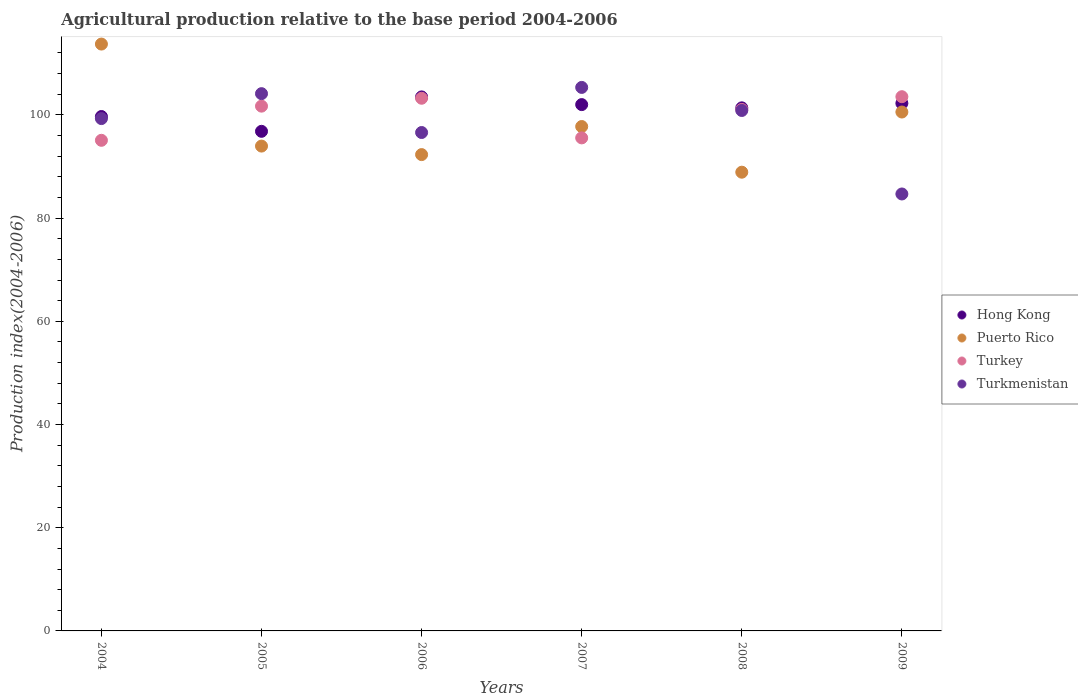How many different coloured dotlines are there?
Keep it short and to the point. 4. Is the number of dotlines equal to the number of legend labels?
Keep it short and to the point. Yes. What is the agricultural production index in Hong Kong in 2009?
Your response must be concise. 102.25. Across all years, what is the maximum agricultural production index in Hong Kong?
Provide a short and direct response. 103.49. Across all years, what is the minimum agricultural production index in Puerto Rico?
Give a very brief answer. 88.9. What is the total agricultural production index in Turkmenistan in the graph?
Make the answer very short. 590.87. What is the difference between the agricultural production index in Turkmenistan in 2004 and that in 2009?
Your response must be concise. 14.61. What is the difference between the agricultural production index in Hong Kong in 2009 and the agricultural production index in Puerto Rico in 2008?
Your answer should be compact. 13.35. What is the average agricultural production index in Puerto Rico per year?
Provide a short and direct response. 97.87. In the year 2005, what is the difference between the agricultural production index in Hong Kong and agricultural production index in Turkey?
Make the answer very short. -4.88. In how many years, is the agricultural production index in Turkmenistan greater than 92?
Give a very brief answer. 5. What is the ratio of the agricultural production index in Puerto Rico in 2006 to that in 2008?
Offer a very short reply. 1.04. Is the agricultural production index in Puerto Rico in 2004 less than that in 2008?
Offer a terse response. No. What is the difference between the highest and the second highest agricultural production index in Puerto Rico?
Offer a terse response. 13.17. What is the difference between the highest and the lowest agricultural production index in Turkey?
Your answer should be very brief. 8.45. In how many years, is the agricultural production index in Turkey greater than the average agricultural production index in Turkey taken over all years?
Give a very brief answer. 4. Is it the case that in every year, the sum of the agricultural production index in Turkmenistan and agricultural production index in Hong Kong  is greater than the agricultural production index in Puerto Rico?
Your response must be concise. Yes. Does the agricultural production index in Turkmenistan monotonically increase over the years?
Your answer should be very brief. No. Is the agricultural production index in Puerto Rico strictly greater than the agricultural production index in Turkmenistan over the years?
Provide a short and direct response. No. How many dotlines are there?
Ensure brevity in your answer.  4. How many years are there in the graph?
Your answer should be compact. 6. What is the difference between two consecutive major ticks on the Y-axis?
Ensure brevity in your answer.  20. Does the graph contain any zero values?
Provide a short and direct response. No. Where does the legend appear in the graph?
Keep it short and to the point. Center right. How are the legend labels stacked?
Ensure brevity in your answer.  Vertical. What is the title of the graph?
Offer a terse response. Agricultural production relative to the base period 2004-2006. Does "Liberia" appear as one of the legend labels in the graph?
Give a very brief answer. No. What is the label or title of the Y-axis?
Offer a terse response. Production index(2004-2006). What is the Production index(2004-2006) of Hong Kong in 2004?
Your answer should be compact. 99.69. What is the Production index(2004-2006) in Puerto Rico in 2004?
Offer a very short reply. 113.73. What is the Production index(2004-2006) in Turkey in 2004?
Your answer should be very brief. 95.08. What is the Production index(2004-2006) in Turkmenistan in 2004?
Give a very brief answer. 99.29. What is the Production index(2004-2006) in Hong Kong in 2005?
Ensure brevity in your answer.  96.82. What is the Production index(2004-2006) of Puerto Rico in 2005?
Your answer should be compact. 93.96. What is the Production index(2004-2006) of Turkey in 2005?
Provide a succinct answer. 101.7. What is the Production index(2004-2006) of Turkmenistan in 2005?
Provide a succinct answer. 104.12. What is the Production index(2004-2006) of Hong Kong in 2006?
Keep it short and to the point. 103.49. What is the Production index(2004-2006) in Puerto Rico in 2006?
Provide a short and direct response. 92.31. What is the Production index(2004-2006) in Turkey in 2006?
Give a very brief answer. 103.23. What is the Production index(2004-2006) of Turkmenistan in 2006?
Your answer should be compact. 96.59. What is the Production index(2004-2006) in Hong Kong in 2007?
Offer a terse response. 102. What is the Production index(2004-2006) in Puerto Rico in 2007?
Make the answer very short. 97.75. What is the Production index(2004-2006) of Turkey in 2007?
Your response must be concise. 95.55. What is the Production index(2004-2006) in Turkmenistan in 2007?
Your answer should be compact. 105.33. What is the Production index(2004-2006) of Hong Kong in 2008?
Ensure brevity in your answer.  101.37. What is the Production index(2004-2006) of Puerto Rico in 2008?
Keep it short and to the point. 88.9. What is the Production index(2004-2006) of Turkey in 2008?
Your answer should be compact. 101.06. What is the Production index(2004-2006) of Turkmenistan in 2008?
Your response must be concise. 100.86. What is the Production index(2004-2006) in Hong Kong in 2009?
Your answer should be very brief. 102.25. What is the Production index(2004-2006) in Puerto Rico in 2009?
Provide a succinct answer. 100.56. What is the Production index(2004-2006) in Turkey in 2009?
Make the answer very short. 103.53. What is the Production index(2004-2006) of Turkmenistan in 2009?
Give a very brief answer. 84.68. Across all years, what is the maximum Production index(2004-2006) in Hong Kong?
Your response must be concise. 103.49. Across all years, what is the maximum Production index(2004-2006) of Puerto Rico?
Keep it short and to the point. 113.73. Across all years, what is the maximum Production index(2004-2006) of Turkey?
Your response must be concise. 103.53. Across all years, what is the maximum Production index(2004-2006) of Turkmenistan?
Your answer should be compact. 105.33. Across all years, what is the minimum Production index(2004-2006) of Hong Kong?
Provide a succinct answer. 96.82. Across all years, what is the minimum Production index(2004-2006) of Puerto Rico?
Ensure brevity in your answer.  88.9. Across all years, what is the minimum Production index(2004-2006) of Turkey?
Offer a very short reply. 95.08. Across all years, what is the minimum Production index(2004-2006) of Turkmenistan?
Your answer should be compact. 84.68. What is the total Production index(2004-2006) in Hong Kong in the graph?
Your answer should be very brief. 605.62. What is the total Production index(2004-2006) in Puerto Rico in the graph?
Provide a succinct answer. 587.21. What is the total Production index(2004-2006) in Turkey in the graph?
Provide a succinct answer. 600.15. What is the total Production index(2004-2006) in Turkmenistan in the graph?
Offer a terse response. 590.87. What is the difference between the Production index(2004-2006) in Hong Kong in 2004 and that in 2005?
Offer a very short reply. 2.87. What is the difference between the Production index(2004-2006) in Puerto Rico in 2004 and that in 2005?
Give a very brief answer. 19.77. What is the difference between the Production index(2004-2006) of Turkey in 2004 and that in 2005?
Offer a terse response. -6.62. What is the difference between the Production index(2004-2006) of Turkmenistan in 2004 and that in 2005?
Your answer should be compact. -4.83. What is the difference between the Production index(2004-2006) in Puerto Rico in 2004 and that in 2006?
Ensure brevity in your answer.  21.42. What is the difference between the Production index(2004-2006) of Turkey in 2004 and that in 2006?
Provide a short and direct response. -8.15. What is the difference between the Production index(2004-2006) in Turkmenistan in 2004 and that in 2006?
Give a very brief answer. 2.7. What is the difference between the Production index(2004-2006) of Hong Kong in 2004 and that in 2007?
Keep it short and to the point. -2.31. What is the difference between the Production index(2004-2006) in Puerto Rico in 2004 and that in 2007?
Your answer should be compact. 15.98. What is the difference between the Production index(2004-2006) of Turkey in 2004 and that in 2007?
Ensure brevity in your answer.  -0.47. What is the difference between the Production index(2004-2006) in Turkmenistan in 2004 and that in 2007?
Keep it short and to the point. -6.04. What is the difference between the Production index(2004-2006) of Hong Kong in 2004 and that in 2008?
Provide a short and direct response. -1.68. What is the difference between the Production index(2004-2006) of Puerto Rico in 2004 and that in 2008?
Make the answer very short. 24.83. What is the difference between the Production index(2004-2006) in Turkey in 2004 and that in 2008?
Make the answer very short. -5.98. What is the difference between the Production index(2004-2006) in Turkmenistan in 2004 and that in 2008?
Provide a short and direct response. -1.57. What is the difference between the Production index(2004-2006) of Hong Kong in 2004 and that in 2009?
Your answer should be very brief. -2.56. What is the difference between the Production index(2004-2006) in Puerto Rico in 2004 and that in 2009?
Offer a terse response. 13.17. What is the difference between the Production index(2004-2006) in Turkey in 2004 and that in 2009?
Keep it short and to the point. -8.45. What is the difference between the Production index(2004-2006) of Turkmenistan in 2004 and that in 2009?
Offer a very short reply. 14.61. What is the difference between the Production index(2004-2006) of Hong Kong in 2005 and that in 2006?
Ensure brevity in your answer.  -6.67. What is the difference between the Production index(2004-2006) in Puerto Rico in 2005 and that in 2006?
Your response must be concise. 1.65. What is the difference between the Production index(2004-2006) of Turkey in 2005 and that in 2006?
Offer a terse response. -1.53. What is the difference between the Production index(2004-2006) in Turkmenistan in 2005 and that in 2006?
Offer a very short reply. 7.53. What is the difference between the Production index(2004-2006) in Hong Kong in 2005 and that in 2007?
Provide a succinct answer. -5.18. What is the difference between the Production index(2004-2006) in Puerto Rico in 2005 and that in 2007?
Your answer should be compact. -3.79. What is the difference between the Production index(2004-2006) of Turkey in 2005 and that in 2007?
Make the answer very short. 6.15. What is the difference between the Production index(2004-2006) of Turkmenistan in 2005 and that in 2007?
Offer a terse response. -1.21. What is the difference between the Production index(2004-2006) in Hong Kong in 2005 and that in 2008?
Offer a very short reply. -4.55. What is the difference between the Production index(2004-2006) of Puerto Rico in 2005 and that in 2008?
Your answer should be compact. 5.06. What is the difference between the Production index(2004-2006) in Turkey in 2005 and that in 2008?
Your response must be concise. 0.64. What is the difference between the Production index(2004-2006) in Turkmenistan in 2005 and that in 2008?
Keep it short and to the point. 3.26. What is the difference between the Production index(2004-2006) in Hong Kong in 2005 and that in 2009?
Your answer should be compact. -5.43. What is the difference between the Production index(2004-2006) in Puerto Rico in 2005 and that in 2009?
Make the answer very short. -6.6. What is the difference between the Production index(2004-2006) of Turkey in 2005 and that in 2009?
Ensure brevity in your answer.  -1.83. What is the difference between the Production index(2004-2006) in Turkmenistan in 2005 and that in 2009?
Make the answer very short. 19.44. What is the difference between the Production index(2004-2006) in Hong Kong in 2006 and that in 2007?
Your answer should be very brief. 1.49. What is the difference between the Production index(2004-2006) in Puerto Rico in 2006 and that in 2007?
Provide a succinct answer. -5.44. What is the difference between the Production index(2004-2006) in Turkey in 2006 and that in 2007?
Your answer should be compact. 7.68. What is the difference between the Production index(2004-2006) in Turkmenistan in 2006 and that in 2007?
Offer a terse response. -8.74. What is the difference between the Production index(2004-2006) in Hong Kong in 2006 and that in 2008?
Your answer should be compact. 2.12. What is the difference between the Production index(2004-2006) in Puerto Rico in 2006 and that in 2008?
Your response must be concise. 3.41. What is the difference between the Production index(2004-2006) in Turkey in 2006 and that in 2008?
Provide a short and direct response. 2.17. What is the difference between the Production index(2004-2006) of Turkmenistan in 2006 and that in 2008?
Give a very brief answer. -4.27. What is the difference between the Production index(2004-2006) in Hong Kong in 2006 and that in 2009?
Provide a succinct answer. 1.24. What is the difference between the Production index(2004-2006) in Puerto Rico in 2006 and that in 2009?
Give a very brief answer. -8.25. What is the difference between the Production index(2004-2006) of Turkmenistan in 2006 and that in 2009?
Ensure brevity in your answer.  11.91. What is the difference between the Production index(2004-2006) of Hong Kong in 2007 and that in 2008?
Your answer should be very brief. 0.63. What is the difference between the Production index(2004-2006) of Puerto Rico in 2007 and that in 2008?
Give a very brief answer. 8.85. What is the difference between the Production index(2004-2006) of Turkey in 2007 and that in 2008?
Make the answer very short. -5.51. What is the difference between the Production index(2004-2006) in Turkmenistan in 2007 and that in 2008?
Offer a very short reply. 4.47. What is the difference between the Production index(2004-2006) in Hong Kong in 2007 and that in 2009?
Your response must be concise. -0.25. What is the difference between the Production index(2004-2006) of Puerto Rico in 2007 and that in 2009?
Make the answer very short. -2.81. What is the difference between the Production index(2004-2006) of Turkey in 2007 and that in 2009?
Ensure brevity in your answer.  -7.98. What is the difference between the Production index(2004-2006) in Turkmenistan in 2007 and that in 2009?
Offer a very short reply. 20.65. What is the difference between the Production index(2004-2006) of Hong Kong in 2008 and that in 2009?
Your answer should be very brief. -0.88. What is the difference between the Production index(2004-2006) of Puerto Rico in 2008 and that in 2009?
Provide a short and direct response. -11.66. What is the difference between the Production index(2004-2006) in Turkey in 2008 and that in 2009?
Your answer should be compact. -2.47. What is the difference between the Production index(2004-2006) in Turkmenistan in 2008 and that in 2009?
Your answer should be compact. 16.18. What is the difference between the Production index(2004-2006) in Hong Kong in 2004 and the Production index(2004-2006) in Puerto Rico in 2005?
Offer a very short reply. 5.73. What is the difference between the Production index(2004-2006) in Hong Kong in 2004 and the Production index(2004-2006) in Turkey in 2005?
Offer a terse response. -2.01. What is the difference between the Production index(2004-2006) of Hong Kong in 2004 and the Production index(2004-2006) of Turkmenistan in 2005?
Keep it short and to the point. -4.43. What is the difference between the Production index(2004-2006) of Puerto Rico in 2004 and the Production index(2004-2006) of Turkey in 2005?
Your response must be concise. 12.03. What is the difference between the Production index(2004-2006) of Puerto Rico in 2004 and the Production index(2004-2006) of Turkmenistan in 2005?
Keep it short and to the point. 9.61. What is the difference between the Production index(2004-2006) of Turkey in 2004 and the Production index(2004-2006) of Turkmenistan in 2005?
Offer a very short reply. -9.04. What is the difference between the Production index(2004-2006) in Hong Kong in 2004 and the Production index(2004-2006) in Puerto Rico in 2006?
Your answer should be very brief. 7.38. What is the difference between the Production index(2004-2006) of Hong Kong in 2004 and the Production index(2004-2006) of Turkey in 2006?
Provide a short and direct response. -3.54. What is the difference between the Production index(2004-2006) of Hong Kong in 2004 and the Production index(2004-2006) of Turkmenistan in 2006?
Provide a succinct answer. 3.1. What is the difference between the Production index(2004-2006) in Puerto Rico in 2004 and the Production index(2004-2006) in Turkey in 2006?
Ensure brevity in your answer.  10.5. What is the difference between the Production index(2004-2006) of Puerto Rico in 2004 and the Production index(2004-2006) of Turkmenistan in 2006?
Your answer should be compact. 17.14. What is the difference between the Production index(2004-2006) of Turkey in 2004 and the Production index(2004-2006) of Turkmenistan in 2006?
Provide a succinct answer. -1.51. What is the difference between the Production index(2004-2006) of Hong Kong in 2004 and the Production index(2004-2006) of Puerto Rico in 2007?
Provide a succinct answer. 1.94. What is the difference between the Production index(2004-2006) in Hong Kong in 2004 and the Production index(2004-2006) in Turkey in 2007?
Provide a short and direct response. 4.14. What is the difference between the Production index(2004-2006) of Hong Kong in 2004 and the Production index(2004-2006) of Turkmenistan in 2007?
Your response must be concise. -5.64. What is the difference between the Production index(2004-2006) in Puerto Rico in 2004 and the Production index(2004-2006) in Turkey in 2007?
Your answer should be compact. 18.18. What is the difference between the Production index(2004-2006) in Puerto Rico in 2004 and the Production index(2004-2006) in Turkmenistan in 2007?
Provide a succinct answer. 8.4. What is the difference between the Production index(2004-2006) of Turkey in 2004 and the Production index(2004-2006) of Turkmenistan in 2007?
Provide a short and direct response. -10.25. What is the difference between the Production index(2004-2006) of Hong Kong in 2004 and the Production index(2004-2006) of Puerto Rico in 2008?
Ensure brevity in your answer.  10.79. What is the difference between the Production index(2004-2006) of Hong Kong in 2004 and the Production index(2004-2006) of Turkey in 2008?
Ensure brevity in your answer.  -1.37. What is the difference between the Production index(2004-2006) of Hong Kong in 2004 and the Production index(2004-2006) of Turkmenistan in 2008?
Provide a short and direct response. -1.17. What is the difference between the Production index(2004-2006) of Puerto Rico in 2004 and the Production index(2004-2006) of Turkey in 2008?
Your answer should be compact. 12.67. What is the difference between the Production index(2004-2006) of Puerto Rico in 2004 and the Production index(2004-2006) of Turkmenistan in 2008?
Offer a very short reply. 12.87. What is the difference between the Production index(2004-2006) of Turkey in 2004 and the Production index(2004-2006) of Turkmenistan in 2008?
Keep it short and to the point. -5.78. What is the difference between the Production index(2004-2006) of Hong Kong in 2004 and the Production index(2004-2006) of Puerto Rico in 2009?
Your answer should be compact. -0.87. What is the difference between the Production index(2004-2006) in Hong Kong in 2004 and the Production index(2004-2006) in Turkey in 2009?
Offer a terse response. -3.84. What is the difference between the Production index(2004-2006) in Hong Kong in 2004 and the Production index(2004-2006) in Turkmenistan in 2009?
Keep it short and to the point. 15.01. What is the difference between the Production index(2004-2006) of Puerto Rico in 2004 and the Production index(2004-2006) of Turkmenistan in 2009?
Offer a very short reply. 29.05. What is the difference between the Production index(2004-2006) in Hong Kong in 2005 and the Production index(2004-2006) in Puerto Rico in 2006?
Offer a very short reply. 4.51. What is the difference between the Production index(2004-2006) in Hong Kong in 2005 and the Production index(2004-2006) in Turkey in 2006?
Your answer should be compact. -6.41. What is the difference between the Production index(2004-2006) in Hong Kong in 2005 and the Production index(2004-2006) in Turkmenistan in 2006?
Your answer should be very brief. 0.23. What is the difference between the Production index(2004-2006) of Puerto Rico in 2005 and the Production index(2004-2006) of Turkey in 2006?
Make the answer very short. -9.27. What is the difference between the Production index(2004-2006) of Puerto Rico in 2005 and the Production index(2004-2006) of Turkmenistan in 2006?
Offer a terse response. -2.63. What is the difference between the Production index(2004-2006) of Turkey in 2005 and the Production index(2004-2006) of Turkmenistan in 2006?
Your response must be concise. 5.11. What is the difference between the Production index(2004-2006) of Hong Kong in 2005 and the Production index(2004-2006) of Puerto Rico in 2007?
Your answer should be compact. -0.93. What is the difference between the Production index(2004-2006) of Hong Kong in 2005 and the Production index(2004-2006) of Turkey in 2007?
Your answer should be very brief. 1.27. What is the difference between the Production index(2004-2006) of Hong Kong in 2005 and the Production index(2004-2006) of Turkmenistan in 2007?
Your answer should be very brief. -8.51. What is the difference between the Production index(2004-2006) of Puerto Rico in 2005 and the Production index(2004-2006) of Turkey in 2007?
Give a very brief answer. -1.59. What is the difference between the Production index(2004-2006) in Puerto Rico in 2005 and the Production index(2004-2006) in Turkmenistan in 2007?
Your response must be concise. -11.37. What is the difference between the Production index(2004-2006) in Turkey in 2005 and the Production index(2004-2006) in Turkmenistan in 2007?
Give a very brief answer. -3.63. What is the difference between the Production index(2004-2006) of Hong Kong in 2005 and the Production index(2004-2006) of Puerto Rico in 2008?
Your answer should be compact. 7.92. What is the difference between the Production index(2004-2006) in Hong Kong in 2005 and the Production index(2004-2006) in Turkey in 2008?
Your response must be concise. -4.24. What is the difference between the Production index(2004-2006) of Hong Kong in 2005 and the Production index(2004-2006) of Turkmenistan in 2008?
Keep it short and to the point. -4.04. What is the difference between the Production index(2004-2006) of Puerto Rico in 2005 and the Production index(2004-2006) of Turkmenistan in 2008?
Offer a terse response. -6.9. What is the difference between the Production index(2004-2006) in Turkey in 2005 and the Production index(2004-2006) in Turkmenistan in 2008?
Your answer should be very brief. 0.84. What is the difference between the Production index(2004-2006) of Hong Kong in 2005 and the Production index(2004-2006) of Puerto Rico in 2009?
Provide a short and direct response. -3.74. What is the difference between the Production index(2004-2006) in Hong Kong in 2005 and the Production index(2004-2006) in Turkey in 2009?
Offer a terse response. -6.71. What is the difference between the Production index(2004-2006) in Hong Kong in 2005 and the Production index(2004-2006) in Turkmenistan in 2009?
Offer a very short reply. 12.14. What is the difference between the Production index(2004-2006) in Puerto Rico in 2005 and the Production index(2004-2006) in Turkey in 2009?
Keep it short and to the point. -9.57. What is the difference between the Production index(2004-2006) of Puerto Rico in 2005 and the Production index(2004-2006) of Turkmenistan in 2009?
Your answer should be very brief. 9.28. What is the difference between the Production index(2004-2006) of Turkey in 2005 and the Production index(2004-2006) of Turkmenistan in 2009?
Your response must be concise. 17.02. What is the difference between the Production index(2004-2006) in Hong Kong in 2006 and the Production index(2004-2006) in Puerto Rico in 2007?
Make the answer very short. 5.74. What is the difference between the Production index(2004-2006) of Hong Kong in 2006 and the Production index(2004-2006) of Turkey in 2007?
Your answer should be very brief. 7.94. What is the difference between the Production index(2004-2006) in Hong Kong in 2006 and the Production index(2004-2006) in Turkmenistan in 2007?
Give a very brief answer. -1.84. What is the difference between the Production index(2004-2006) in Puerto Rico in 2006 and the Production index(2004-2006) in Turkey in 2007?
Ensure brevity in your answer.  -3.24. What is the difference between the Production index(2004-2006) of Puerto Rico in 2006 and the Production index(2004-2006) of Turkmenistan in 2007?
Ensure brevity in your answer.  -13.02. What is the difference between the Production index(2004-2006) of Turkey in 2006 and the Production index(2004-2006) of Turkmenistan in 2007?
Make the answer very short. -2.1. What is the difference between the Production index(2004-2006) of Hong Kong in 2006 and the Production index(2004-2006) of Puerto Rico in 2008?
Offer a very short reply. 14.59. What is the difference between the Production index(2004-2006) of Hong Kong in 2006 and the Production index(2004-2006) of Turkey in 2008?
Provide a short and direct response. 2.43. What is the difference between the Production index(2004-2006) of Hong Kong in 2006 and the Production index(2004-2006) of Turkmenistan in 2008?
Your response must be concise. 2.63. What is the difference between the Production index(2004-2006) in Puerto Rico in 2006 and the Production index(2004-2006) in Turkey in 2008?
Provide a short and direct response. -8.75. What is the difference between the Production index(2004-2006) in Puerto Rico in 2006 and the Production index(2004-2006) in Turkmenistan in 2008?
Ensure brevity in your answer.  -8.55. What is the difference between the Production index(2004-2006) of Turkey in 2006 and the Production index(2004-2006) of Turkmenistan in 2008?
Ensure brevity in your answer.  2.37. What is the difference between the Production index(2004-2006) in Hong Kong in 2006 and the Production index(2004-2006) in Puerto Rico in 2009?
Offer a very short reply. 2.93. What is the difference between the Production index(2004-2006) in Hong Kong in 2006 and the Production index(2004-2006) in Turkey in 2009?
Make the answer very short. -0.04. What is the difference between the Production index(2004-2006) in Hong Kong in 2006 and the Production index(2004-2006) in Turkmenistan in 2009?
Your response must be concise. 18.81. What is the difference between the Production index(2004-2006) of Puerto Rico in 2006 and the Production index(2004-2006) of Turkey in 2009?
Provide a succinct answer. -11.22. What is the difference between the Production index(2004-2006) of Puerto Rico in 2006 and the Production index(2004-2006) of Turkmenistan in 2009?
Offer a very short reply. 7.63. What is the difference between the Production index(2004-2006) in Turkey in 2006 and the Production index(2004-2006) in Turkmenistan in 2009?
Your response must be concise. 18.55. What is the difference between the Production index(2004-2006) in Hong Kong in 2007 and the Production index(2004-2006) in Turkmenistan in 2008?
Give a very brief answer. 1.14. What is the difference between the Production index(2004-2006) of Puerto Rico in 2007 and the Production index(2004-2006) of Turkey in 2008?
Your answer should be compact. -3.31. What is the difference between the Production index(2004-2006) of Puerto Rico in 2007 and the Production index(2004-2006) of Turkmenistan in 2008?
Keep it short and to the point. -3.11. What is the difference between the Production index(2004-2006) in Turkey in 2007 and the Production index(2004-2006) in Turkmenistan in 2008?
Give a very brief answer. -5.31. What is the difference between the Production index(2004-2006) in Hong Kong in 2007 and the Production index(2004-2006) in Puerto Rico in 2009?
Offer a terse response. 1.44. What is the difference between the Production index(2004-2006) in Hong Kong in 2007 and the Production index(2004-2006) in Turkey in 2009?
Your answer should be compact. -1.53. What is the difference between the Production index(2004-2006) in Hong Kong in 2007 and the Production index(2004-2006) in Turkmenistan in 2009?
Offer a terse response. 17.32. What is the difference between the Production index(2004-2006) in Puerto Rico in 2007 and the Production index(2004-2006) in Turkey in 2009?
Your answer should be very brief. -5.78. What is the difference between the Production index(2004-2006) of Puerto Rico in 2007 and the Production index(2004-2006) of Turkmenistan in 2009?
Provide a succinct answer. 13.07. What is the difference between the Production index(2004-2006) in Turkey in 2007 and the Production index(2004-2006) in Turkmenistan in 2009?
Ensure brevity in your answer.  10.87. What is the difference between the Production index(2004-2006) in Hong Kong in 2008 and the Production index(2004-2006) in Puerto Rico in 2009?
Your answer should be very brief. 0.81. What is the difference between the Production index(2004-2006) of Hong Kong in 2008 and the Production index(2004-2006) of Turkey in 2009?
Keep it short and to the point. -2.16. What is the difference between the Production index(2004-2006) in Hong Kong in 2008 and the Production index(2004-2006) in Turkmenistan in 2009?
Ensure brevity in your answer.  16.69. What is the difference between the Production index(2004-2006) in Puerto Rico in 2008 and the Production index(2004-2006) in Turkey in 2009?
Offer a very short reply. -14.63. What is the difference between the Production index(2004-2006) of Puerto Rico in 2008 and the Production index(2004-2006) of Turkmenistan in 2009?
Your answer should be very brief. 4.22. What is the difference between the Production index(2004-2006) of Turkey in 2008 and the Production index(2004-2006) of Turkmenistan in 2009?
Keep it short and to the point. 16.38. What is the average Production index(2004-2006) in Hong Kong per year?
Your answer should be compact. 100.94. What is the average Production index(2004-2006) in Puerto Rico per year?
Offer a terse response. 97.87. What is the average Production index(2004-2006) of Turkey per year?
Your response must be concise. 100.03. What is the average Production index(2004-2006) of Turkmenistan per year?
Your response must be concise. 98.48. In the year 2004, what is the difference between the Production index(2004-2006) in Hong Kong and Production index(2004-2006) in Puerto Rico?
Provide a succinct answer. -14.04. In the year 2004, what is the difference between the Production index(2004-2006) in Hong Kong and Production index(2004-2006) in Turkey?
Give a very brief answer. 4.61. In the year 2004, what is the difference between the Production index(2004-2006) in Puerto Rico and Production index(2004-2006) in Turkey?
Provide a succinct answer. 18.65. In the year 2004, what is the difference between the Production index(2004-2006) of Puerto Rico and Production index(2004-2006) of Turkmenistan?
Ensure brevity in your answer.  14.44. In the year 2004, what is the difference between the Production index(2004-2006) of Turkey and Production index(2004-2006) of Turkmenistan?
Your answer should be compact. -4.21. In the year 2005, what is the difference between the Production index(2004-2006) in Hong Kong and Production index(2004-2006) in Puerto Rico?
Give a very brief answer. 2.86. In the year 2005, what is the difference between the Production index(2004-2006) in Hong Kong and Production index(2004-2006) in Turkey?
Your answer should be very brief. -4.88. In the year 2005, what is the difference between the Production index(2004-2006) of Hong Kong and Production index(2004-2006) of Turkmenistan?
Offer a very short reply. -7.3. In the year 2005, what is the difference between the Production index(2004-2006) in Puerto Rico and Production index(2004-2006) in Turkey?
Ensure brevity in your answer.  -7.74. In the year 2005, what is the difference between the Production index(2004-2006) in Puerto Rico and Production index(2004-2006) in Turkmenistan?
Your answer should be very brief. -10.16. In the year 2005, what is the difference between the Production index(2004-2006) in Turkey and Production index(2004-2006) in Turkmenistan?
Provide a short and direct response. -2.42. In the year 2006, what is the difference between the Production index(2004-2006) of Hong Kong and Production index(2004-2006) of Puerto Rico?
Keep it short and to the point. 11.18. In the year 2006, what is the difference between the Production index(2004-2006) of Hong Kong and Production index(2004-2006) of Turkey?
Ensure brevity in your answer.  0.26. In the year 2006, what is the difference between the Production index(2004-2006) in Puerto Rico and Production index(2004-2006) in Turkey?
Provide a short and direct response. -10.92. In the year 2006, what is the difference between the Production index(2004-2006) of Puerto Rico and Production index(2004-2006) of Turkmenistan?
Provide a succinct answer. -4.28. In the year 2006, what is the difference between the Production index(2004-2006) in Turkey and Production index(2004-2006) in Turkmenistan?
Ensure brevity in your answer.  6.64. In the year 2007, what is the difference between the Production index(2004-2006) of Hong Kong and Production index(2004-2006) of Puerto Rico?
Provide a short and direct response. 4.25. In the year 2007, what is the difference between the Production index(2004-2006) in Hong Kong and Production index(2004-2006) in Turkey?
Provide a short and direct response. 6.45. In the year 2007, what is the difference between the Production index(2004-2006) in Hong Kong and Production index(2004-2006) in Turkmenistan?
Offer a very short reply. -3.33. In the year 2007, what is the difference between the Production index(2004-2006) in Puerto Rico and Production index(2004-2006) in Turkey?
Provide a short and direct response. 2.2. In the year 2007, what is the difference between the Production index(2004-2006) of Puerto Rico and Production index(2004-2006) of Turkmenistan?
Offer a very short reply. -7.58. In the year 2007, what is the difference between the Production index(2004-2006) in Turkey and Production index(2004-2006) in Turkmenistan?
Offer a very short reply. -9.78. In the year 2008, what is the difference between the Production index(2004-2006) in Hong Kong and Production index(2004-2006) in Puerto Rico?
Your response must be concise. 12.47. In the year 2008, what is the difference between the Production index(2004-2006) in Hong Kong and Production index(2004-2006) in Turkey?
Ensure brevity in your answer.  0.31. In the year 2008, what is the difference between the Production index(2004-2006) in Hong Kong and Production index(2004-2006) in Turkmenistan?
Your response must be concise. 0.51. In the year 2008, what is the difference between the Production index(2004-2006) of Puerto Rico and Production index(2004-2006) of Turkey?
Provide a short and direct response. -12.16. In the year 2008, what is the difference between the Production index(2004-2006) in Puerto Rico and Production index(2004-2006) in Turkmenistan?
Make the answer very short. -11.96. In the year 2009, what is the difference between the Production index(2004-2006) in Hong Kong and Production index(2004-2006) in Puerto Rico?
Make the answer very short. 1.69. In the year 2009, what is the difference between the Production index(2004-2006) of Hong Kong and Production index(2004-2006) of Turkey?
Ensure brevity in your answer.  -1.28. In the year 2009, what is the difference between the Production index(2004-2006) in Hong Kong and Production index(2004-2006) in Turkmenistan?
Your response must be concise. 17.57. In the year 2009, what is the difference between the Production index(2004-2006) of Puerto Rico and Production index(2004-2006) of Turkey?
Provide a short and direct response. -2.97. In the year 2009, what is the difference between the Production index(2004-2006) in Puerto Rico and Production index(2004-2006) in Turkmenistan?
Make the answer very short. 15.88. In the year 2009, what is the difference between the Production index(2004-2006) in Turkey and Production index(2004-2006) in Turkmenistan?
Give a very brief answer. 18.85. What is the ratio of the Production index(2004-2006) of Hong Kong in 2004 to that in 2005?
Offer a terse response. 1.03. What is the ratio of the Production index(2004-2006) of Puerto Rico in 2004 to that in 2005?
Offer a terse response. 1.21. What is the ratio of the Production index(2004-2006) in Turkey in 2004 to that in 2005?
Provide a short and direct response. 0.93. What is the ratio of the Production index(2004-2006) in Turkmenistan in 2004 to that in 2005?
Provide a short and direct response. 0.95. What is the ratio of the Production index(2004-2006) of Hong Kong in 2004 to that in 2006?
Offer a terse response. 0.96. What is the ratio of the Production index(2004-2006) of Puerto Rico in 2004 to that in 2006?
Give a very brief answer. 1.23. What is the ratio of the Production index(2004-2006) in Turkey in 2004 to that in 2006?
Keep it short and to the point. 0.92. What is the ratio of the Production index(2004-2006) of Turkmenistan in 2004 to that in 2006?
Provide a succinct answer. 1.03. What is the ratio of the Production index(2004-2006) in Hong Kong in 2004 to that in 2007?
Your answer should be compact. 0.98. What is the ratio of the Production index(2004-2006) of Puerto Rico in 2004 to that in 2007?
Offer a terse response. 1.16. What is the ratio of the Production index(2004-2006) of Turkey in 2004 to that in 2007?
Your response must be concise. 1. What is the ratio of the Production index(2004-2006) of Turkmenistan in 2004 to that in 2007?
Provide a succinct answer. 0.94. What is the ratio of the Production index(2004-2006) in Hong Kong in 2004 to that in 2008?
Your response must be concise. 0.98. What is the ratio of the Production index(2004-2006) of Puerto Rico in 2004 to that in 2008?
Provide a short and direct response. 1.28. What is the ratio of the Production index(2004-2006) in Turkey in 2004 to that in 2008?
Provide a short and direct response. 0.94. What is the ratio of the Production index(2004-2006) of Turkmenistan in 2004 to that in 2008?
Your response must be concise. 0.98. What is the ratio of the Production index(2004-2006) of Puerto Rico in 2004 to that in 2009?
Your answer should be very brief. 1.13. What is the ratio of the Production index(2004-2006) of Turkey in 2004 to that in 2009?
Make the answer very short. 0.92. What is the ratio of the Production index(2004-2006) in Turkmenistan in 2004 to that in 2009?
Your response must be concise. 1.17. What is the ratio of the Production index(2004-2006) in Hong Kong in 2005 to that in 2006?
Keep it short and to the point. 0.94. What is the ratio of the Production index(2004-2006) of Puerto Rico in 2005 to that in 2006?
Your response must be concise. 1.02. What is the ratio of the Production index(2004-2006) of Turkey in 2005 to that in 2006?
Make the answer very short. 0.99. What is the ratio of the Production index(2004-2006) in Turkmenistan in 2005 to that in 2006?
Ensure brevity in your answer.  1.08. What is the ratio of the Production index(2004-2006) in Hong Kong in 2005 to that in 2007?
Give a very brief answer. 0.95. What is the ratio of the Production index(2004-2006) in Puerto Rico in 2005 to that in 2007?
Keep it short and to the point. 0.96. What is the ratio of the Production index(2004-2006) of Turkey in 2005 to that in 2007?
Provide a short and direct response. 1.06. What is the ratio of the Production index(2004-2006) of Turkmenistan in 2005 to that in 2007?
Provide a short and direct response. 0.99. What is the ratio of the Production index(2004-2006) in Hong Kong in 2005 to that in 2008?
Provide a short and direct response. 0.96. What is the ratio of the Production index(2004-2006) of Puerto Rico in 2005 to that in 2008?
Provide a short and direct response. 1.06. What is the ratio of the Production index(2004-2006) of Turkey in 2005 to that in 2008?
Your response must be concise. 1.01. What is the ratio of the Production index(2004-2006) in Turkmenistan in 2005 to that in 2008?
Offer a very short reply. 1.03. What is the ratio of the Production index(2004-2006) in Hong Kong in 2005 to that in 2009?
Keep it short and to the point. 0.95. What is the ratio of the Production index(2004-2006) in Puerto Rico in 2005 to that in 2009?
Your response must be concise. 0.93. What is the ratio of the Production index(2004-2006) in Turkey in 2005 to that in 2009?
Keep it short and to the point. 0.98. What is the ratio of the Production index(2004-2006) in Turkmenistan in 2005 to that in 2009?
Provide a short and direct response. 1.23. What is the ratio of the Production index(2004-2006) in Hong Kong in 2006 to that in 2007?
Keep it short and to the point. 1.01. What is the ratio of the Production index(2004-2006) in Puerto Rico in 2006 to that in 2007?
Your answer should be compact. 0.94. What is the ratio of the Production index(2004-2006) in Turkey in 2006 to that in 2007?
Provide a short and direct response. 1.08. What is the ratio of the Production index(2004-2006) in Turkmenistan in 2006 to that in 2007?
Your answer should be very brief. 0.92. What is the ratio of the Production index(2004-2006) in Hong Kong in 2006 to that in 2008?
Offer a terse response. 1.02. What is the ratio of the Production index(2004-2006) in Puerto Rico in 2006 to that in 2008?
Offer a very short reply. 1.04. What is the ratio of the Production index(2004-2006) of Turkey in 2006 to that in 2008?
Ensure brevity in your answer.  1.02. What is the ratio of the Production index(2004-2006) in Turkmenistan in 2006 to that in 2008?
Make the answer very short. 0.96. What is the ratio of the Production index(2004-2006) in Hong Kong in 2006 to that in 2009?
Your answer should be compact. 1.01. What is the ratio of the Production index(2004-2006) of Puerto Rico in 2006 to that in 2009?
Make the answer very short. 0.92. What is the ratio of the Production index(2004-2006) of Turkey in 2006 to that in 2009?
Make the answer very short. 1. What is the ratio of the Production index(2004-2006) in Turkmenistan in 2006 to that in 2009?
Your answer should be very brief. 1.14. What is the ratio of the Production index(2004-2006) in Hong Kong in 2007 to that in 2008?
Ensure brevity in your answer.  1.01. What is the ratio of the Production index(2004-2006) in Puerto Rico in 2007 to that in 2008?
Give a very brief answer. 1.1. What is the ratio of the Production index(2004-2006) in Turkey in 2007 to that in 2008?
Make the answer very short. 0.95. What is the ratio of the Production index(2004-2006) in Turkmenistan in 2007 to that in 2008?
Your response must be concise. 1.04. What is the ratio of the Production index(2004-2006) of Puerto Rico in 2007 to that in 2009?
Offer a very short reply. 0.97. What is the ratio of the Production index(2004-2006) in Turkey in 2007 to that in 2009?
Ensure brevity in your answer.  0.92. What is the ratio of the Production index(2004-2006) of Turkmenistan in 2007 to that in 2009?
Make the answer very short. 1.24. What is the ratio of the Production index(2004-2006) of Puerto Rico in 2008 to that in 2009?
Your answer should be very brief. 0.88. What is the ratio of the Production index(2004-2006) in Turkey in 2008 to that in 2009?
Offer a terse response. 0.98. What is the ratio of the Production index(2004-2006) in Turkmenistan in 2008 to that in 2009?
Provide a short and direct response. 1.19. What is the difference between the highest and the second highest Production index(2004-2006) in Hong Kong?
Your answer should be very brief. 1.24. What is the difference between the highest and the second highest Production index(2004-2006) in Puerto Rico?
Offer a very short reply. 13.17. What is the difference between the highest and the second highest Production index(2004-2006) in Turkey?
Provide a succinct answer. 0.3. What is the difference between the highest and the second highest Production index(2004-2006) of Turkmenistan?
Offer a very short reply. 1.21. What is the difference between the highest and the lowest Production index(2004-2006) in Hong Kong?
Make the answer very short. 6.67. What is the difference between the highest and the lowest Production index(2004-2006) in Puerto Rico?
Your answer should be compact. 24.83. What is the difference between the highest and the lowest Production index(2004-2006) of Turkey?
Provide a succinct answer. 8.45. What is the difference between the highest and the lowest Production index(2004-2006) in Turkmenistan?
Keep it short and to the point. 20.65. 